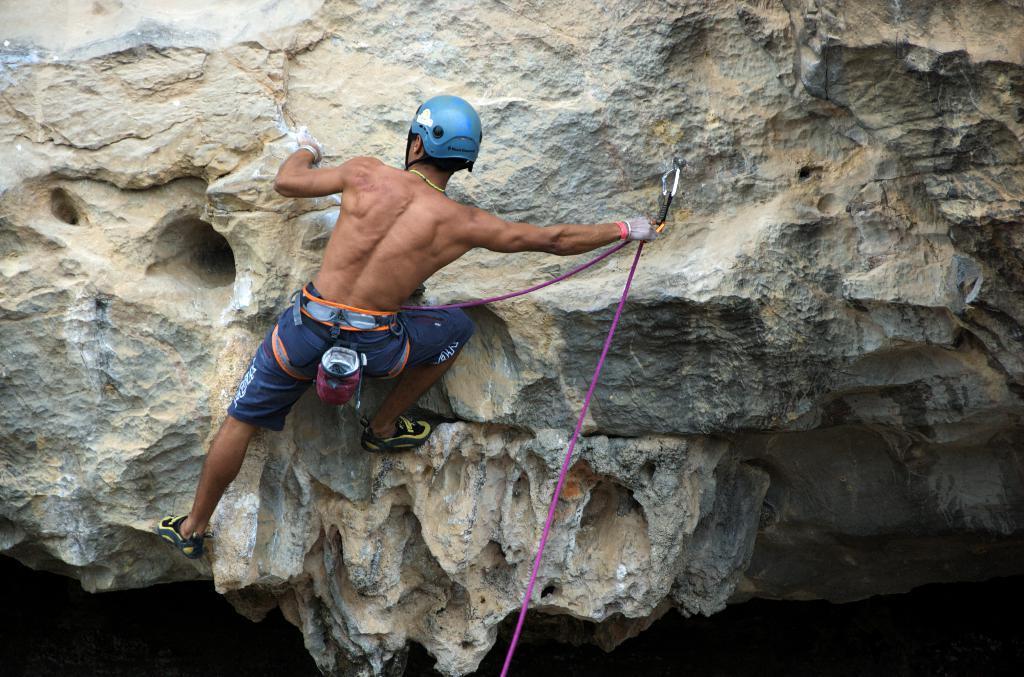Describe this image in one or two sentences. In this image I can see a person is climbing on the rock. 